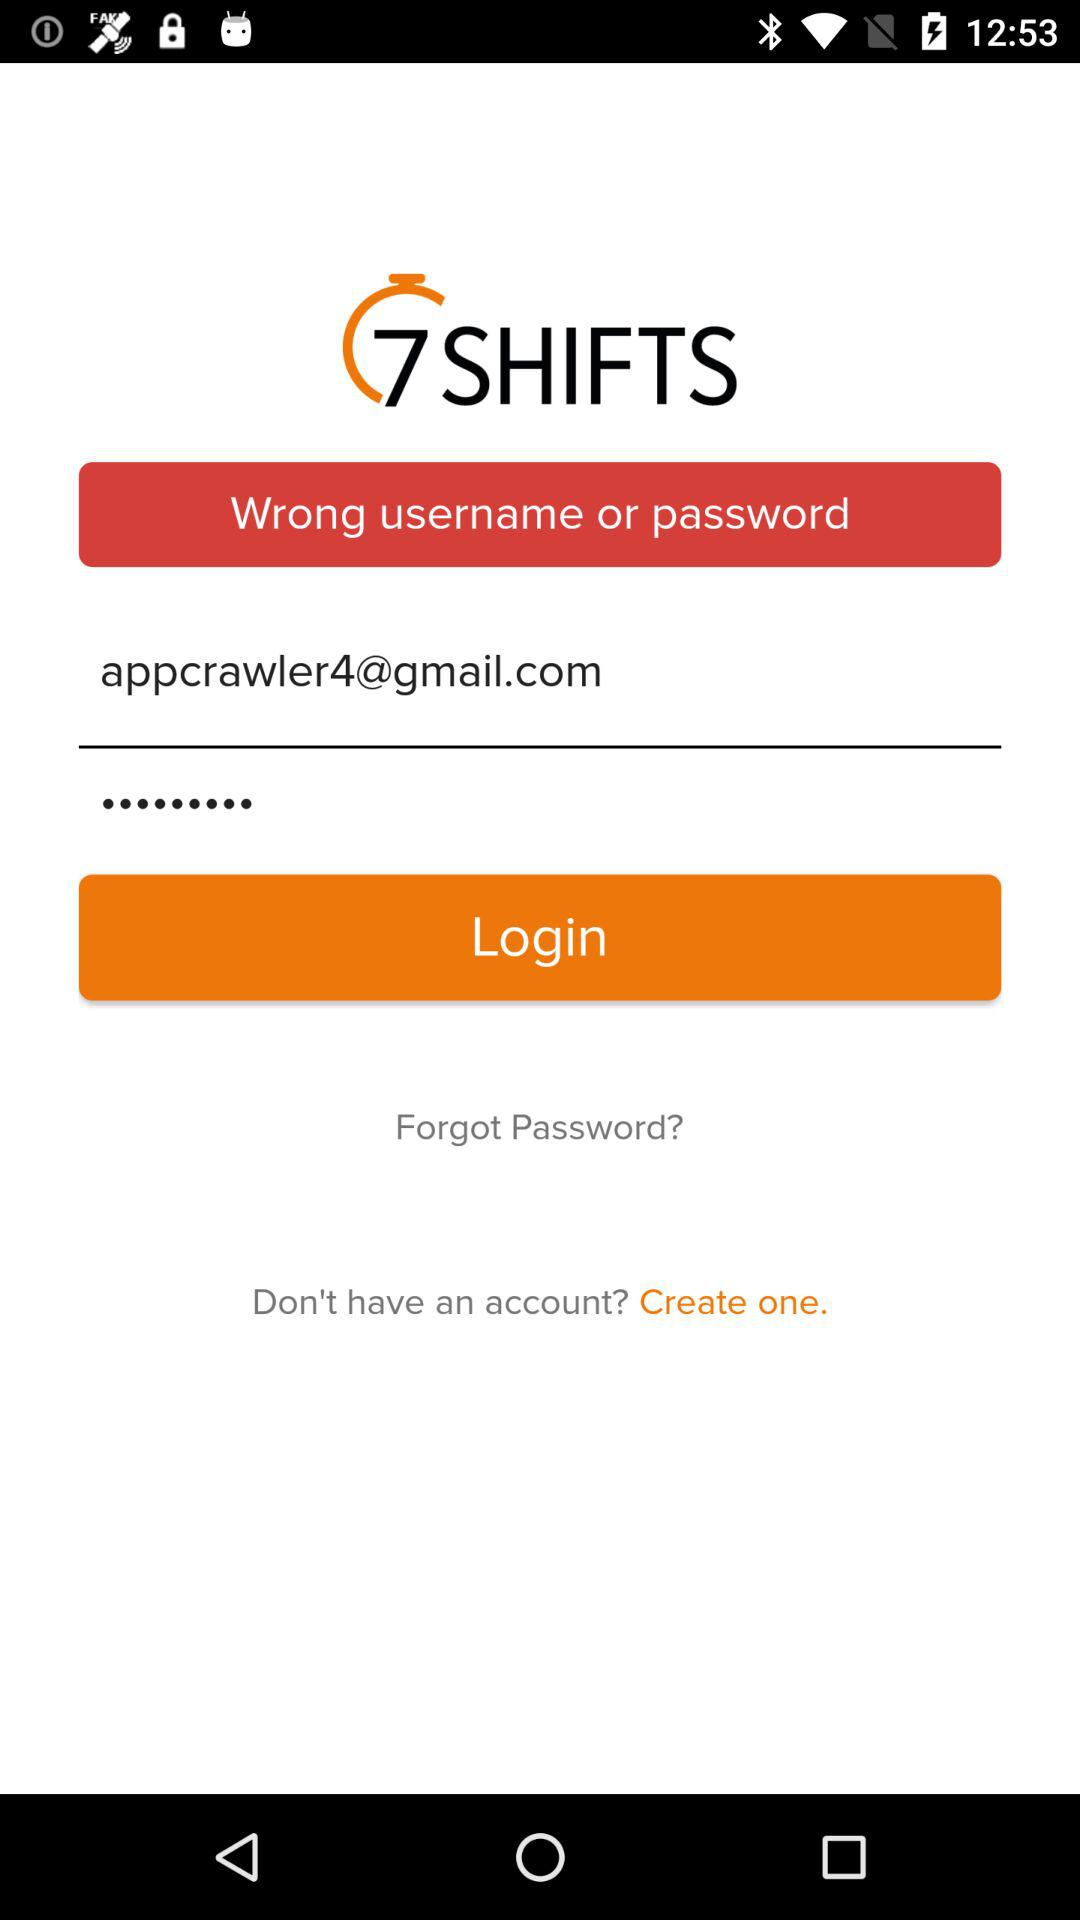What is the name of the application? The name of the application is "7 SHIFTS". 